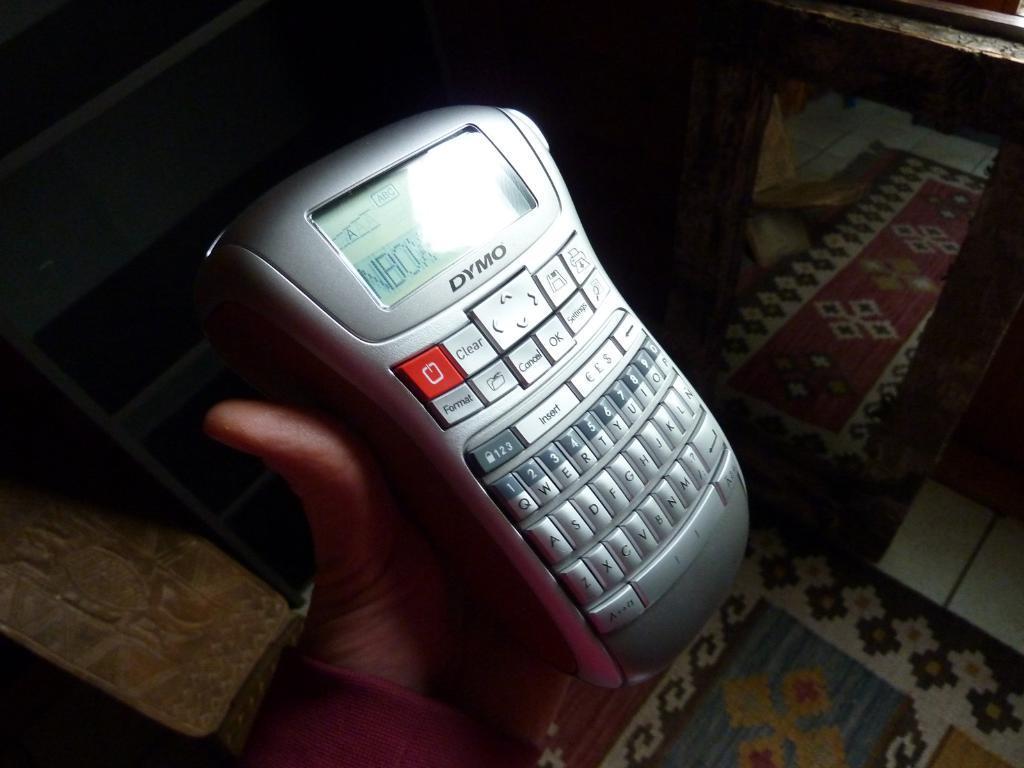Please provide a concise description of this image. In this picture there is a person holding an electronic gadget. At the top there are bag like objects. On the right it is looking like a window. 